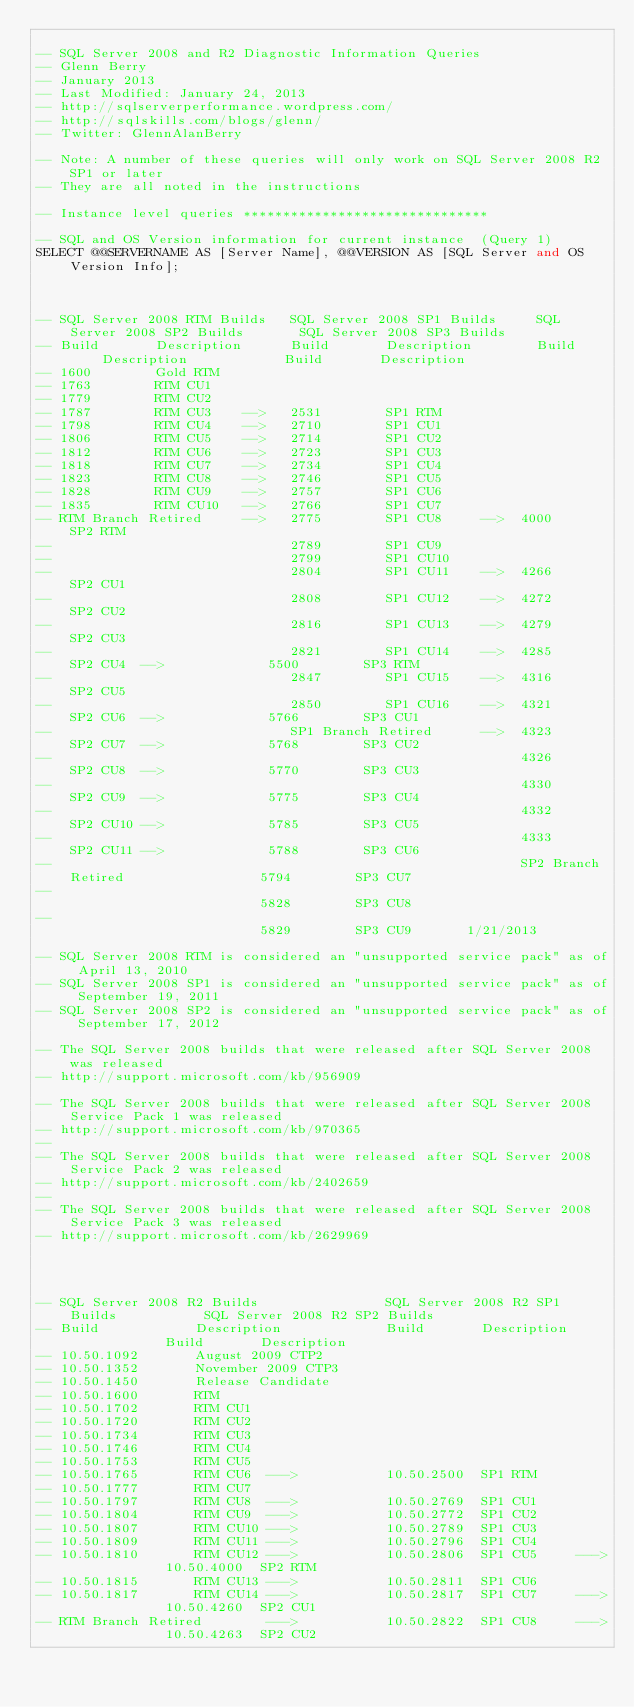<code> <loc_0><loc_0><loc_500><loc_500><_SQL_>
-- SQL Server 2008 and R2 Diagnostic Information Queries
-- Glenn Berry 
-- January 2013
-- Last Modified: January 24, 2013
-- http://sqlserverperformance.wordpress.com/
-- http://sqlskills.com/blogs/glenn/
-- Twitter: GlennAlanBerry

-- Note: A number of these queries will only work on SQL Server 2008 R2 SP1 or later
-- They are all noted in the instructions

-- Instance level queries *******************************

-- SQL and OS Version information for current instance  (Query 1)
SELECT @@SERVERNAME AS [Server Name], @@VERSION AS [SQL Server and OS Version Info];



-- SQL Server 2008 RTM Builds   SQL Server 2008 SP1 Builds     SQL Server 2008 SP2 Builds		SQL Server 2008 SP3 Builds
-- Build       Description      Build       Description		   Build     Description			Build		Description
-- 1600        Gold RTM
-- 1763        RTM CU1
-- 1779        RTM CU2
-- 1787        RTM CU3    -->	2531		SP1 RTM
-- 1798        RTM CU4    -->	2710        SP1 CU1
-- 1806        RTM CU5    -->	2714        SP1 CU2 
-- 1812		   RTM CU6    -->	2723        SP1 CU3
-- 1818        RTM CU7    -->	2734        SP1 CU4
-- 1823        RTM CU8    -->	2746		SP1 CU5
-- 1828		   RTM CU9    -->	2757		SP1 CU6
-- 1835		   RTM CU10   -->	2766		SP1 CU7
-- RTM Branch Retired     -->	2775		SP1 CU8		-->  4000	   SP2 RTM
--								2789		SP1 CU9
--								2799		SP1 CU10	
--								2804		SP1 CU11	-->  4266      SP2 CU1		
--								2808		SP1 CU12	-->  4272	   SP2 CU2	
--								2816	    SP1 CU13    -->  4279      SP2 CU3	
--								2821		SP1 CU14	-->  4285	   SP2 CU4	-->				5500		SP3 RTM
--								2847		SP1 CU15	-->  4316	   SP2 CU5  
--								2850		SP1 CU16	-->  4321	   SP2 CU6	-->				5766		SP3 CU1	
--                              SP1 Branch Retired      -->  4323      SP2 CU7  -->             5768        SP3 CU2
--                                                           4326	   SP2 CU8  -->             5770		SP3 CU3
--														     4330	   SP2 CU9  -->				5775		SP3 CU4
--															 4332	   SP2 CU10 -->             5785        SP3 CU5
--															 4333      SP2 CU11 -->			    5788        SP3 CU6
--															 SP2 Branch Retired					5794        SP3 CU7
--																								5828        SP3 CU8
--																								5829        SP3 CU9       1/21/2013

-- SQL Server 2008 RTM is considered an "unsupported service pack" as of April 13, 2010
-- SQL Server 2008 SP1 is considered an "unsupported service pack" as of September 19, 2011
-- SQL Server 2008 SP2 is considered an "unsupported service pack" as of September 17, 2012

-- The SQL Server 2008 builds that were released after SQL Server 2008 was released
-- http://support.microsoft.com/kb/956909

-- The SQL Server 2008 builds that were released after SQL Server 2008 Service Pack 1 was released
-- http://support.microsoft.com/kb/970365
--
-- The SQL Server 2008 builds that were released after SQL Server 2008 Service Pack 2 was released 
-- http://support.microsoft.com/kb/2402659	
--
-- The SQL Server 2008 builds that were released after SQL Server 2008 Service Pack 3 was released
-- http://support.microsoft.com/kb/2629969					   




-- SQL Server 2008 R2 Builds				SQL Server 2008 R2 SP1 Builds			SQL Server 2008 R2 SP2 Builds
-- Build			Description				Build		Description					Build		Description
-- 10.50.1092		August 2009 CTP2		
-- 10.50.1352		November 2009 CTP3
-- 10.50.1450		Release Candidate
-- 10.50.1600		RTM
-- 10.50.1702		RTM CU1
-- 10.50.1720		RTM CU2
-- 10.50.1734		RTM CU3
-- 10.50.1746		RTM CU4
-- 10.50.1753		RTM CU5
-- 10.50.1765		RTM CU6	 --->			10.50.2500	SP1 RTM
-- 10.50.1777		RTM CU7
-- 10.50.1797		RTM CU8	 --->			10.50.2769  SP1 CU1
-- 10.50.1804       RTM CU9  --->			10.50.2772  SP1 CU2
-- 10.50.1807		RTM CU10 --->           10.50.2789  SP1 CU3
-- 10.50.1809       RTM CU11 --->			10.50.2796  SP1 CU4 
-- 10.50.1810		RTM CU12 --->			10.50.2806	SP1 CU5		--->			10.50.4000	SP2 RTM
-- 10.50.1815		RTM CU13 --->           10.50.2811  SP1 CU6
-- 10.50.1817		RTM CU14 --->			10.50.2817  SP1 CU7		--->			10.50.4260	SP2 CU1   
-- RTM Branch Retired        --->			10.50.2822  SP1 CU8     --->			10.50.4263  SP2 CU2    </code> 